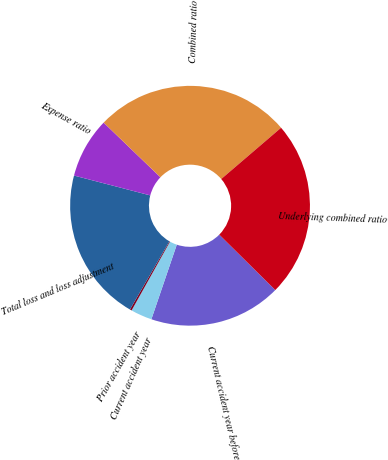Convert chart to OTSL. <chart><loc_0><loc_0><loc_500><loc_500><pie_chart><fcel>Current accident year before<fcel>Current accident year<fcel>Prior accident year<fcel>Total loss and loss adjustment<fcel>Expense ratio<fcel>Combined ratio<fcel>Underlying combined ratio<nl><fcel>17.82%<fcel>2.88%<fcel>0.25%<fcel>20.7%<fcel>8.14%<fcel>26.53%<fcel>23.68%<nl></chart> 